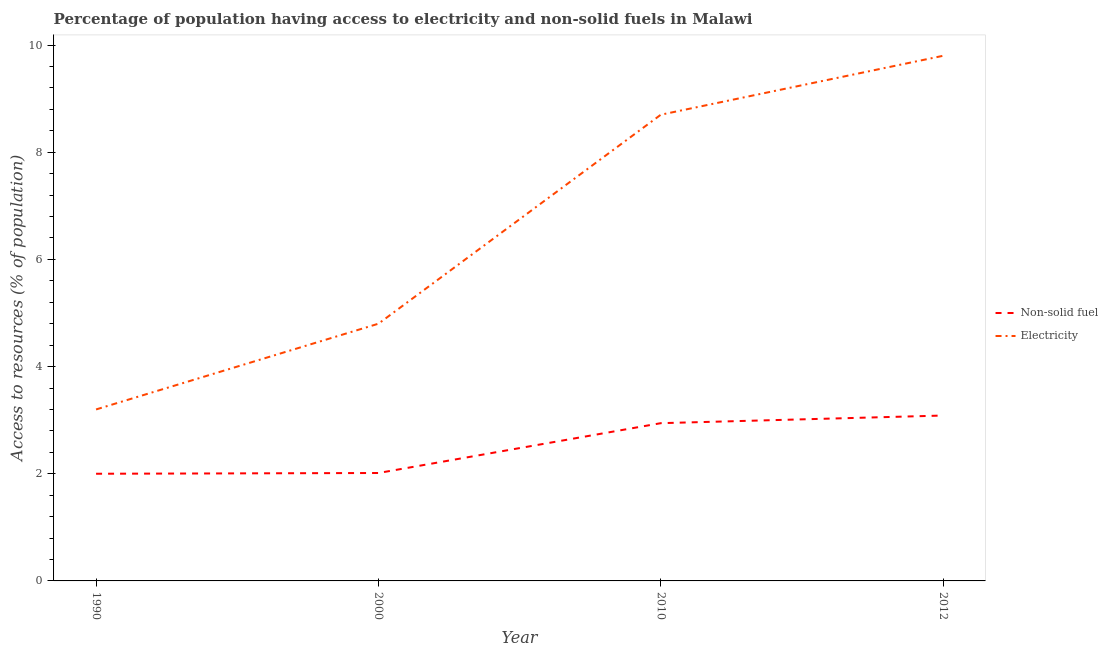How many different coloured lines are there?
Provide a short and direct response. 2. Does the line corresponding to percentage of population having access to electricity intersect with the line corresponding to percentage of population having access to non-solid fuel?
Offer a very short reply. No. What is the percentage of population having access to non-solid fuel in 2010?
Your answer should be very brief. 2.94. Across all years, what is the maximum percentage of population having access to electricity?
Offer a very short reply. 9.8. Across all years, what is the minimum percentage of population having access to non-solid fuel?
Your answer should be very brief. 2. In which year was the percentage of population having access to electricity maximum?
Offer a very short reply. 2012. In which year was the percentage of population having access to non-solid fuel minimum?
Make the answer very short. 1990. What is the total percentage of population having access to non-solid fuel in the graph?
Offer a very short reply. 10.04. What is the difference between the percentage of population having access to non-solid fuel in 1990 and that in 2010?
Provide a succinct answer. -0.94. What is the difference between the percentage of population having access to electricity in 1990 and the percentage of population having access to non-solid fuel in 2000?
Keep it short and to the point. 1.19. What is the average percentage of population having access to electricity per year?
Offer a terse response. 6.62. In the year 1990, what is the difference between the percentage of population having access to electricity and percentage of population having access to non-solid fuel?
Your response must be concise. 1.2. In how many years, is the percentage of population having access to non-solid fuel greater than 4.4 %?
Ensure brevity in your answer.  0. What is the ratio of the percentage of population having access to electricity in 2000 to that in 2012?
Provide a short and direct response. 0.49. Is the percentage of population having access to electricity in 2000 less than that in 2012?
Your response must be concise. Yes. Is the difference between the percentage of population having access to electricity in 2010 and 2012 greater than the difference between the percentage of population having access to non-solid fuel in 2010 and 2012?
Your answer should be very brief. No. What is the difference between the highest and the second highest percentage of population having access to non-solid fuel?
Your answer should be compact. 0.14. What is the difference between the highest and the lowest percentage of population having access to non-solid fuel?
Keep it short and to the point. 1.09. In how many years, is the percentage of population having access to non-solid fuel greater than the average percentage of population having access to non-solid fuel taken over all years?
Make the answer very short. 2. Does the percentage of population having access to electricity monotonically increase over the years?
Offer a terse response. Yes. Is the percentage of population having access to electricity strictly greater than the percentage of population having access to non-solid fuel over the years?
Give a very brief answer. Yes. Is the percentage of population having access to electricity strictly less than the percentage of population having access to non-solid fuel over the years?
Your response must be concise. No. How many years are there in the graph?
Give a very brief answer. 4. Does the graph contain any zero values?
Offer a terse response. No. Where does the legend appear in the graph?
Your answer should be very brief. Center right. How many legend labels are there?
Provide a succinct answer. 2. How are the legend labels stacked?
Your answer should be very brief. Vertical. What is the title of the graph?
Provide a succinct answer. Percentage of population having access to electricity and non-solid fuels in Malawi. What is the label or title of the X-axis?
Keep it short and to the point. Year. What is the label or title of the Y-axis?
Your response must be concise. Access to resources (% of population). What is the Access to resources (% of population) in Non-solid fuel in 1990?
Give a very brief answer. 2. What is the Access to resources (% of population) of Electricity in 1990?
Give a very brief answer. 3.2. What is the Access to resources (% of population) of Non-solid fuel in 2000?
Offer a very short reply. 2.01. What is the Access to resources (% of population) in Electricity in 2000?
Keep it short and to the point. 4.8. What is the Access to resources (% of population) of Non-solid fuel in 2010?
Ensure brevity in your answer.  2.94. What is the Access to resources (% of population) of Electricity in 2010?
Make the answer very short. 8.7. What is the Access to resources (% of population) of Non-solid fuel in 2012?
Provide a short and direct response. 3.09. What is the Access to resources (% of population) in Electricity in 2012?
Make the answer very short. 9.8. Across all years, what is the maximum Access to resources (% of population) in Non-solid fuel?
Ensure brevity in your answer.  3.09. Across all years, what is the maximum Access to resources (% of population) in Electricity?
Provide a succinct answer. 9.8. Across all years, what is the minimum Access to resources (% of population) in Non-solid fuel?
Keep it short and to the point. 2. Across all years, what is the minimum Access to resources (% of population) in Electricity?
Make the answer very short. 3.2. What is the total Access to resources (% of population) of Non-solid fuel in the graph?
Your response must be concise. 10.04. What is the total Access to resources (% of population) in Electricity in the graph?
Offer a very short reply. 26.5. What is the difference between the Access to resources (% of population) in Non-solid fuel in 1990 and that in 2000?
Your answer should be compact. -0.01. What is the difference between the Access to resources (% of population) of Electricity in 1990 and that in 2000?
Provide a short and direct response. -1.6. What is the difference between the Access to resources (% of population) of Non-solid fuel in 1990 and that in 2010?
Your response must be concise. -0.94. What is the difference between the Access to resources (% of population) of Non-solid fuel in 1990 and that in 2012?
Offer a terse response. -1.09. What is the difference between the Access to resources (% of population) in Electricity in 1990 and that in 2012?
Provide a short and direct response. -6.6. What is the difference between the Access to resources (% of population) in Non-solid fuel in 2000 and that in 2010?
Your answer should be compact. -0.93. What is the difference between the Access to resources (% of population) in Electricity in 2000 and that in 2010?
Your answer should be compact. -3.9. What is the difference between the Access to resources (% of population) of Non-solid fuel in 2000 and that in 2012?
Make the answer very short. -1.07. What is the difference between the Access to resources (% of population) of Non-solid fuel in 2010 and that in 2012?
Your answer should be compact. -0.14. What is the difference between the Access to resources (% of population) in Non-solid fuel in 1990 and the Access to resources (% of population) in Electricity in 2010?
Your response must be concise. -6.7. What is the difference between the Access to resources (% of population) of Non-solid fuel in 2000 and the Access to resources (% of population) of Electricity in 2010?
Make the answer very short. -6.69. What is the difference between the Access to resources (% of population) in Non-solid fuel in 2000 and the Access to resources (% of population) in Electricity in 2012?
Your answer should be very brief. -7.79. What is the difference between the Access to resources (% of population) in Non-solid fuel in 2010 and the Access to resources (% of population) in Electricity in 2012?
Ensure brevity in your answer.  -6.86. What is the average Access to resources (% of population) in Non-solid fuel per year?
Provide a short and direct response. 2.51. What is the average Access to resources (% of population) of Electricity per year?
Give a very brief answer. 6.62. In the year 2000, what is the difference between the Access to resources (% of population) of Non-solid fuel and Access to resources (% of population) of Electricity?
Your response must be concise. -2.79. In the year 2010, what is the difference between the Access to resources (% of population) of Non-solid fuel and Access to resources (% of population) of Electricity?
Your response must be concise. -5.76. In the year 2012, what is the difference between the Access to resources (% of population) in Non-solid fuel and Access to resources (% of population) in Electricity?
Give a very brief answer. -6.71. What is the ratio of the Access to resources (% of population) of Non-solid fuel in 1990 to that in 2010?
Keep it short and to the point. 0.68. What is the ratio of the Access to resources (% of population) of Electricity in 1990 to that in 2010?
Give a very brief answer. 0.37. What is the ratio of the Access to resources (% of population) of Non-solid fuel in 1990 to that in 2012?
Your response must be concise. 0.65. What is the ratio of the Access to resources (% of population) of Electricity in 1990 to that in 2012?
Offer a terse response. 0.33. What is the ratio of the Access to resources (% of population) of Non-solid fuel in 2000 to that in 2010?
Your answer should be compact. 0.68. What is the ratio of the Access to resources (% of population) in Electricity in 2000 to that in 2010?
Give a very brief answer. 0.55. What is the ratio of the Access to resources (% of population) of Non-solid fuel in 2000 to that in 2012?
Your response must be concise. 0.65. What is the ratio of the Access to resources (% of population) in Electricity in 2000 to that in 2012?
Offer a very short reply. 0.49. What is the ratio of the Access to resources (% of population) in Non-solid fuel in 2010 to that in 2012?
Offer a terse response. 0.95. What is the ratio of the Access to resources (% of population) in Electricity in 2010 to that in 2012?
Your response must be concise. 0.89. What is the difference between the highest and the second highest Access to resources (% of population) of Non-solid fuel?
Your response must be concise. 0.14. What is the difference between the highest and the second highest Access to resources (% of population) of Electricity?
Offer a very short reply. 1.1. What is the difference between the highest and the lowest Access to resources (% of population) in Non-solid fuel?
Offer a terse response. 1.09. 